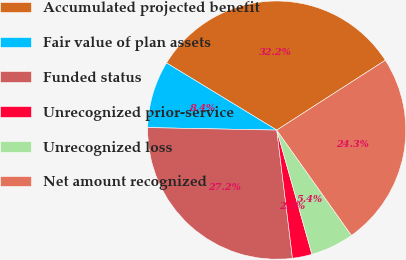<chart> <loc_0><loc_0><loc_500><loc_500><pie_chart><fcel>Accumulated projected benefit<fcel>Fair value of plan assets<fcel>Funded status<fcel>Unrecognized prior-service<fcel>Unrecognized loss<fcel>Net amount recognized<nl><fcel>32.19%<fcel>8.4%<fcel>27.25%<fcel>2.45%<fcel>5.43%<fcel>24.28%<nl></chart> 